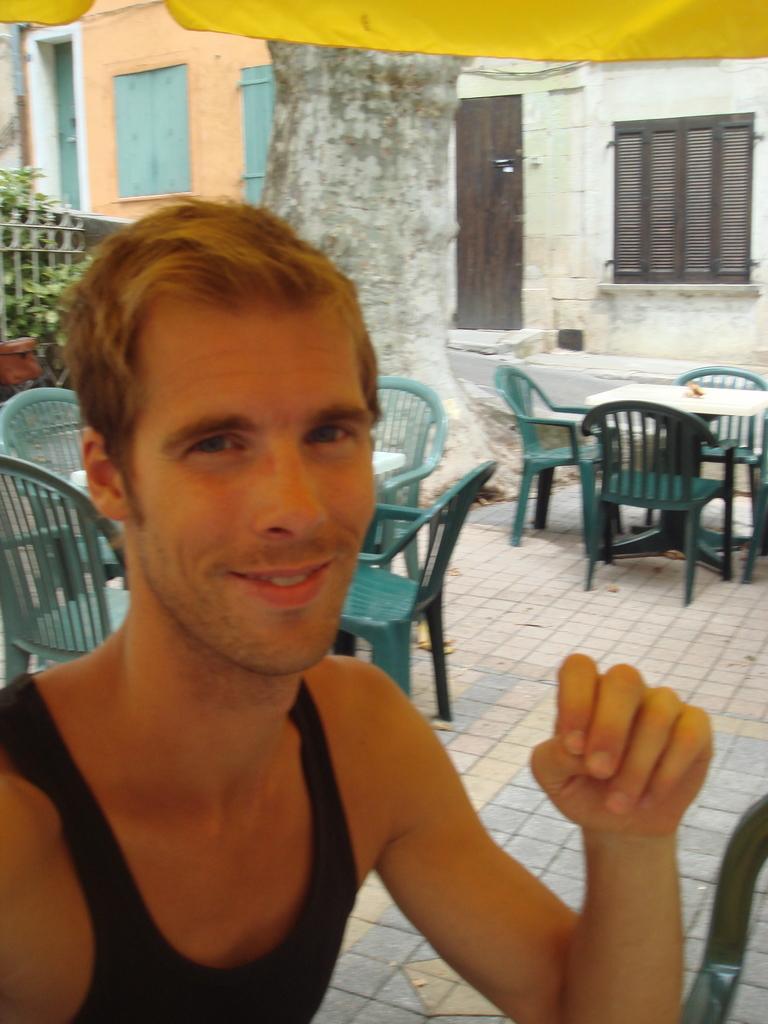In one or two sentences, can you explain what this image depicts? In the image we can see there is a man sitting on the chair and there are chairs and tables kept on the ground. Behind there is a building and there are plants on the ground. 